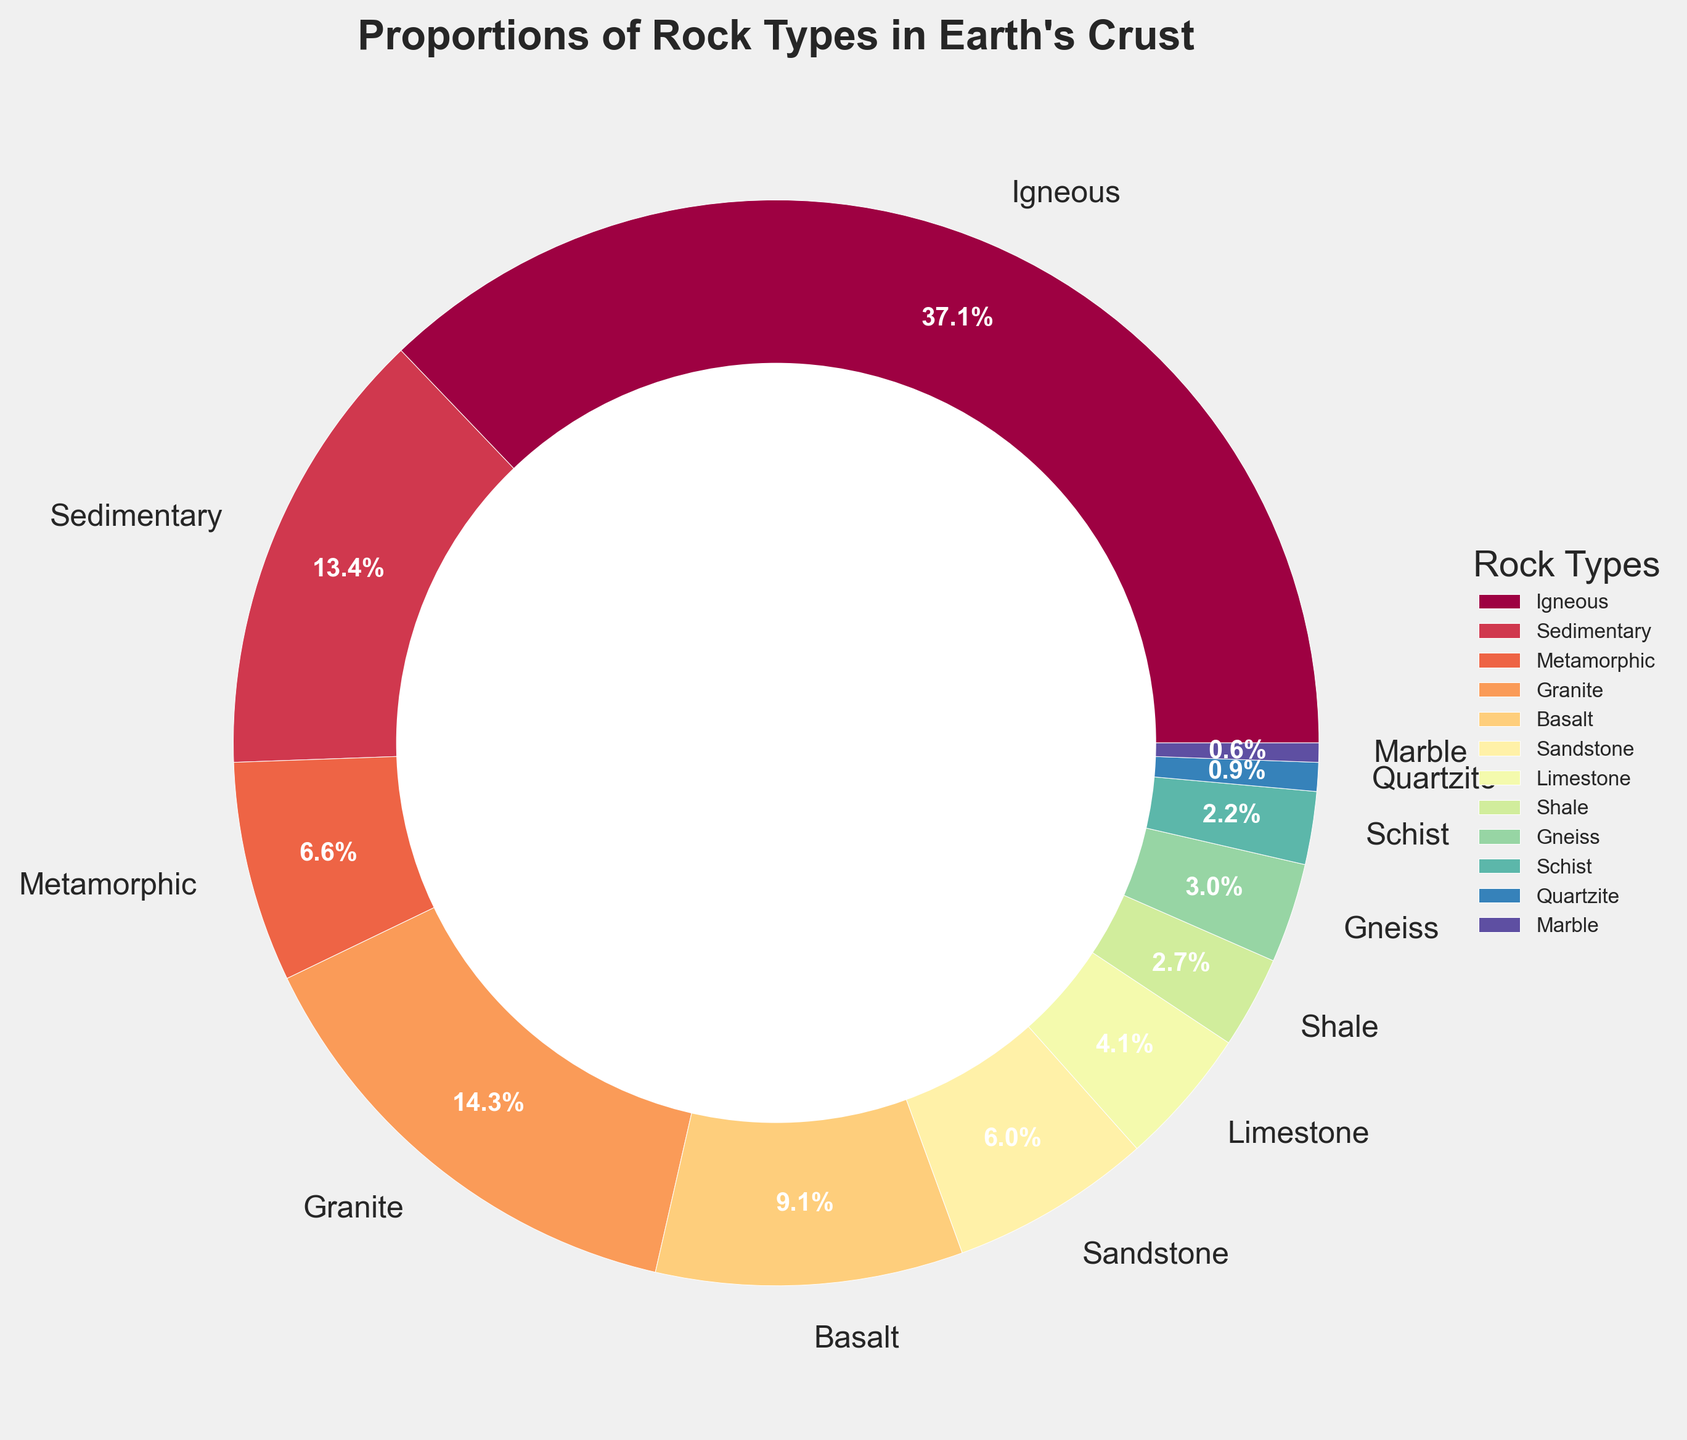What rock type constitutes the largest portion of Earth's crust? The pie chart shows the proportions of different rock types, and the rock type with the largest wedge corresponds to Igneous rocks.
Answer: Igneous Which two rock types combined make up less than 20% of Earth's crust? By examining the pie chart, we can see that Metamorphic (11.5%) and Limestone (7.2%) combined make up 11.5 + 7.2 = 18.7%.
Answer: Metamorphic and Limestone How much larger is the percentage of Granite rock compared to Shale rock? According to the chart, Granite is 25.0% while Shale is 4.8%. The difference is calculated as 25.0 - 4.8 = 20.2%.
Answer: 20.2% Which has a higher proportion in the Earth's crust: Sandstone or Limestone? From the pie chart, Sandstone has a larger wedge than Limestone, indicating a higher percentage (10.5% for Sandstone vs. 7.2% for Limestone).
Answer: Sandstone What is the total percentage of sedimentary rocks represented in the chart? The chart lists Sedimentary rock types: Sandstone (10.5%), Limestone (7.2%), and Shale (4.8%). Adding these gives 10.5 + 7.2 + 4.8 = 22.5%.
Answer: 22.5% Which rock type has the smallest representation in the pie chart? By looking at the wedges, the smallest wedge corresponds to Marble with 1.0%.
Answer: Marble If you combine the percentages of Gneiss and Schist, do they make up more than Quartzite? From the chart, Gneiss (5.2%) and Schist (3.8%) combine to 5.2 + 3.8 = 9.0%, which is greater than Quartzite's 1.5%.
Answer: Yes What is the difference in the proportion of Basalt and Marble in the Earth's crust? According to the chart, Basalt is 16.0% and Marble is 1.0%. The difference is 16.0 - 1.0 = 15.0%.
Answer: 15.0% Which metamorphic rock type makes up the larger percentage of Earth’s crust: Gneiss or Quartzite? By comparing the wedges, Gneiss (5.2%) is larger than Quartzite (1.5%).
Answer: Gneiss 